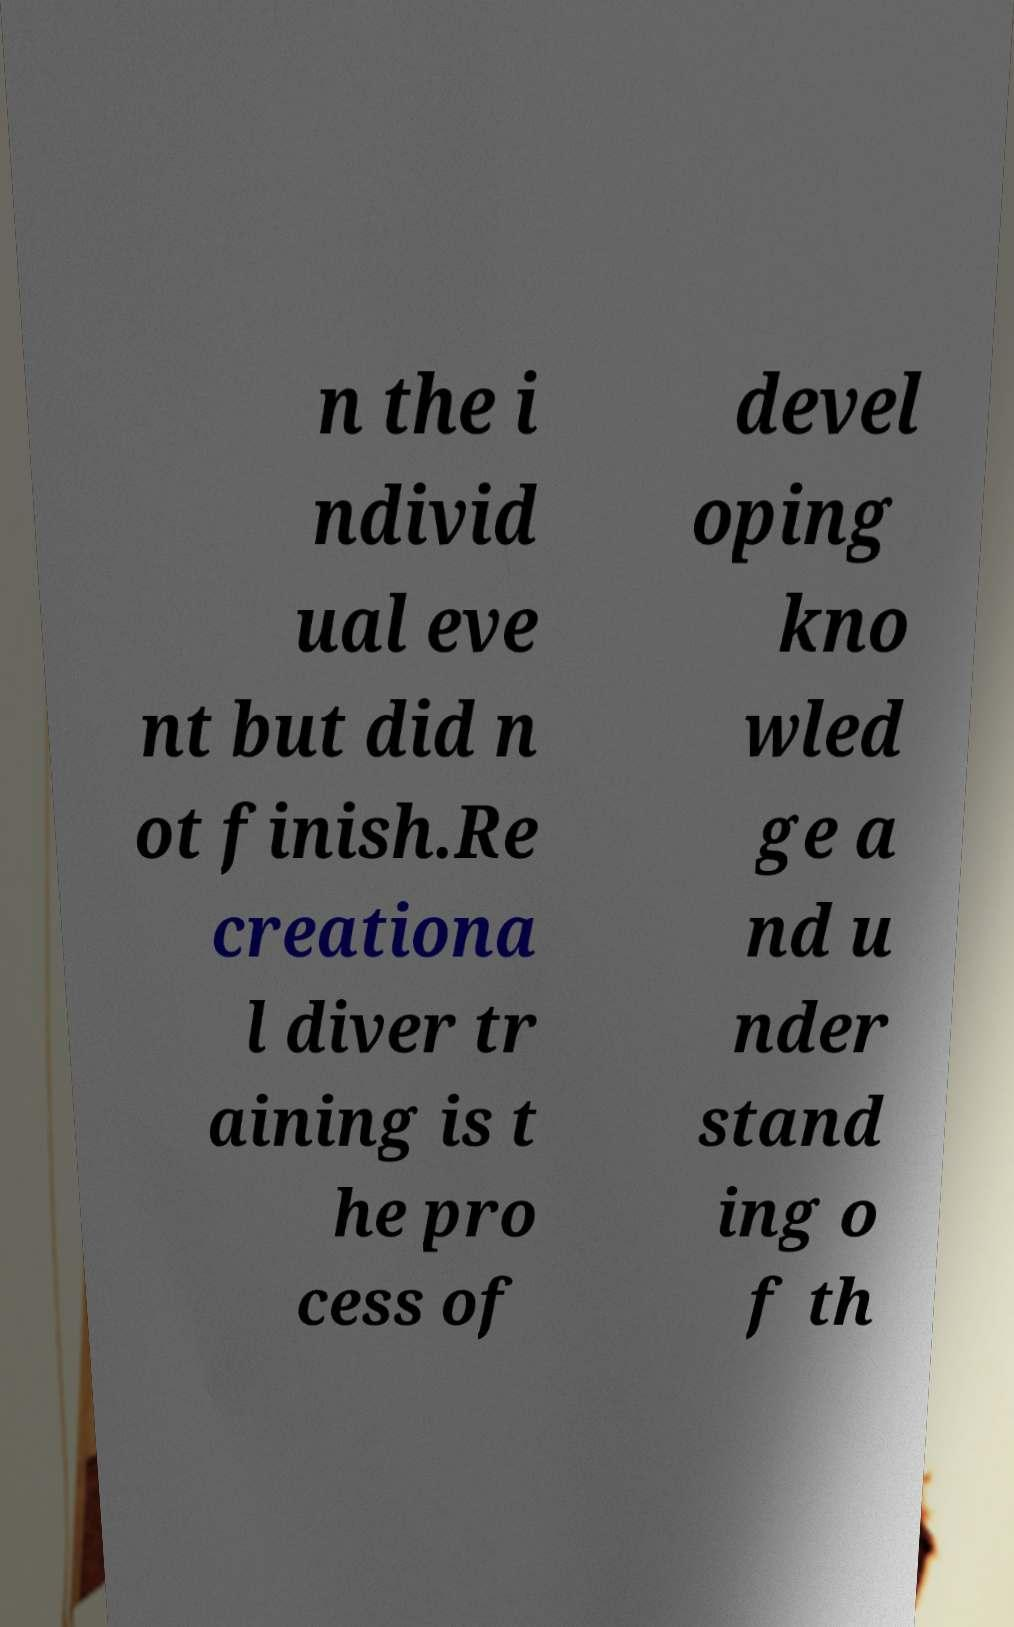There's text embedded in this image that I need extracted. Can you transcribe it verbatim? n the i ndivid ual eve nt but did n ot finish.Re creationa l diver tr aining is t he pro cess of devel oping kno wled ge a nd u nder stand ing o f th 